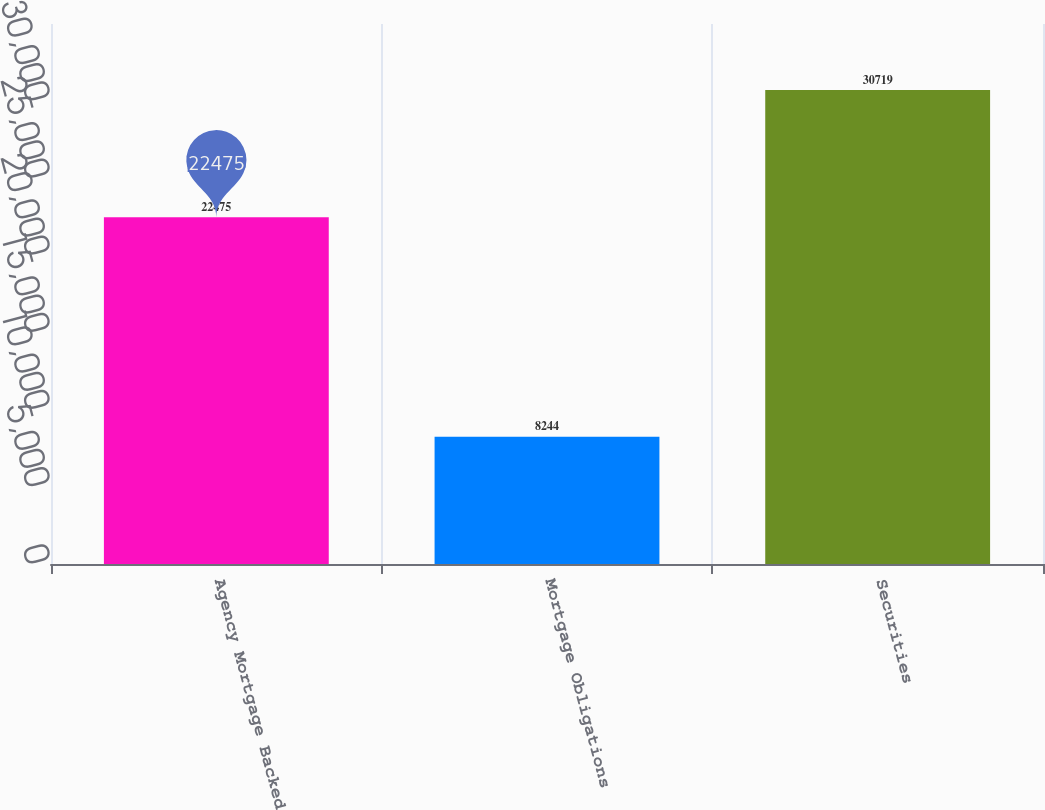Convert chart to OTSL. <chart><loc_0><loc_0><loc_500><loc_500><bar_chart><fcel>Agency Mortgage Backed<fcel>Mortgage Obligations<fcel>Securities<nl><fcel>22475<fcel>8244<fcel>30719<nl></chart> 